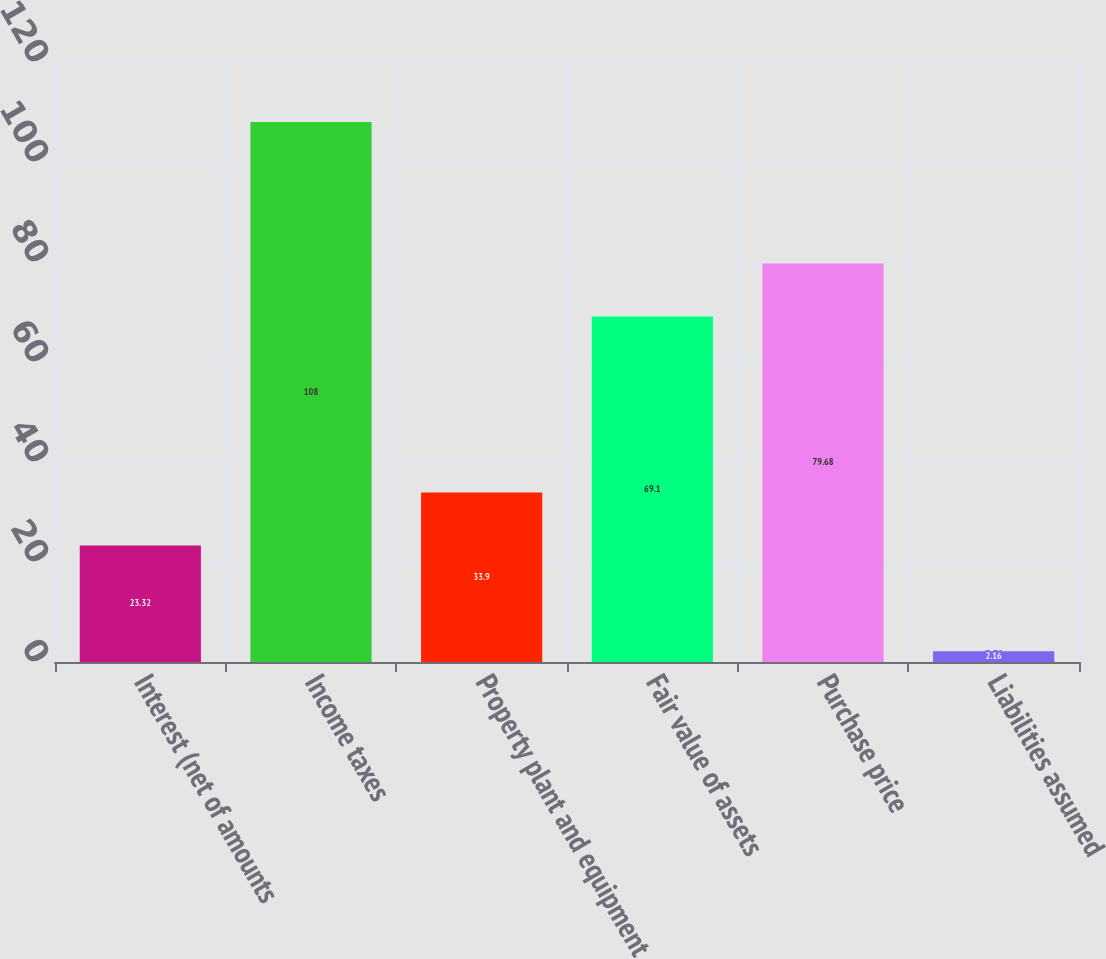<chart> <loc_0><loc_0><loc_500><loc_500><bar_chart><fcel>Interest (net of amounts<fcel>Income taxes<fcel>Property plant and equipment<fcel>Fair value of assets<fcel>Purchase price<fcel>Liabilities assumed<nl><fcel>23.32<fcel>108<fcel>33.9<fcel>69.1<fcel>79.68<fcel>2.16<nl></chart> 